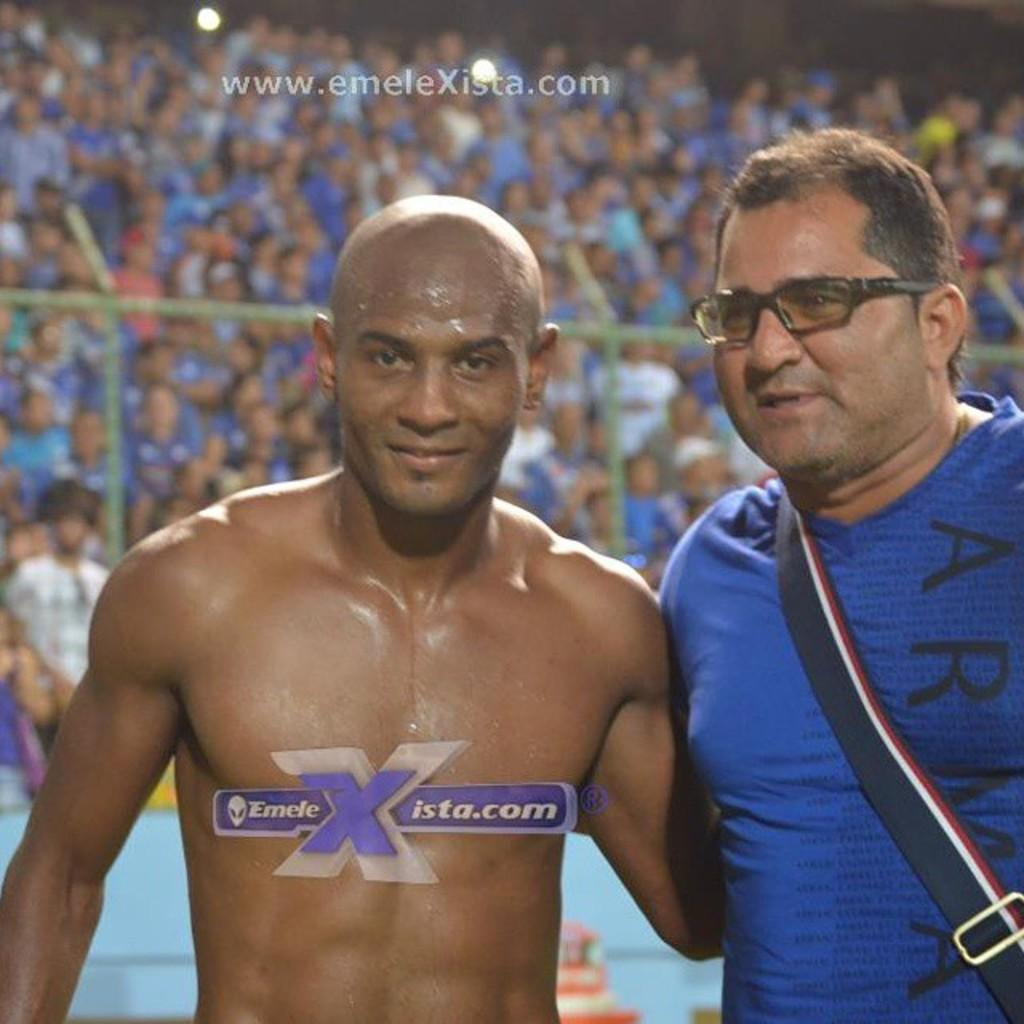Provide a one-sentence caption for the provided image. An athlete poses for a picture for emeleXista.com. 